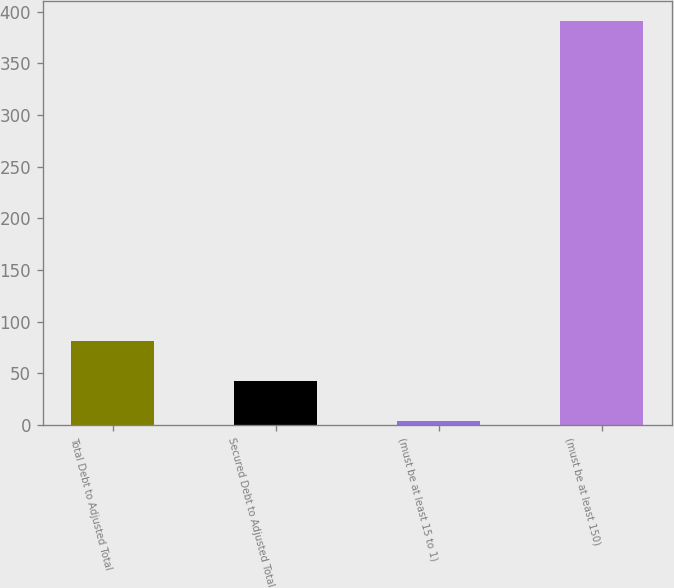Convert chart to OTSL. <chart><loc_0><loc_0><loc_500><loc_500><bar_chart><fcel>Total Debt to Adjusted Total<fcel>Secured Debt to Adjusted Total<fcel>(must be at least 15 to 1)<fcel>(must be at least 150)<nl><fcel>81.15<fcel>42.44<fcel>3.73<fcel>390.8<nl></chart> 